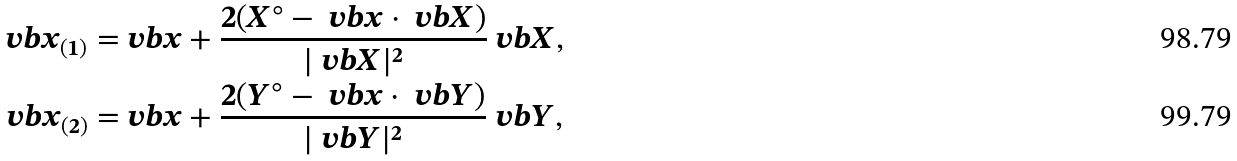<formula> <loc_0><loc_0><loc_500><loc_500>\ v b x _ { ( 1 ) } = & \ v b x + \frac { 2 ( X ^ { \circ } - \ v b x \cdot \ v b X ) } { | \ v b X | ^ { 2 } } \ v b X , \\ \ v b x _ { ( 2 ) } = & \ v b x + \frac { 2 ( Y ^ { \circ } - \ v b x \cdot \ v b Y ) } { | \ v b Y | ^ { 2 } } \ v b Y ,</formula> 